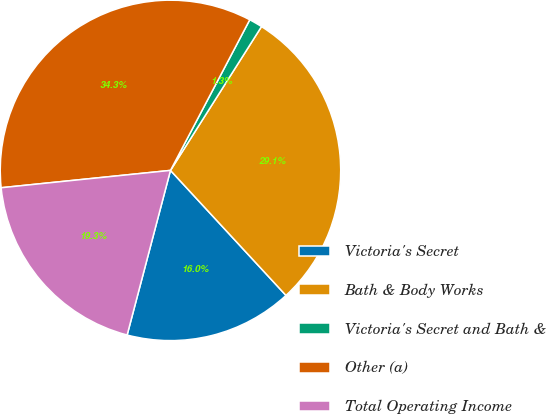Convert chart. <chart><loc_0><loc_0><loc_500><loc_500><pie_chart><fcel>Victoria's Secret<fcel>Bath & Body Works<fcel>Victoria's Secret and Bath &<fcel>Other (a)<fcel>Total Operating Income<nl><fcel>15.97%<fcel>29.15%<fcel>1.27%<fcel>34.34%<fcel>19.28%<nl></chart> 